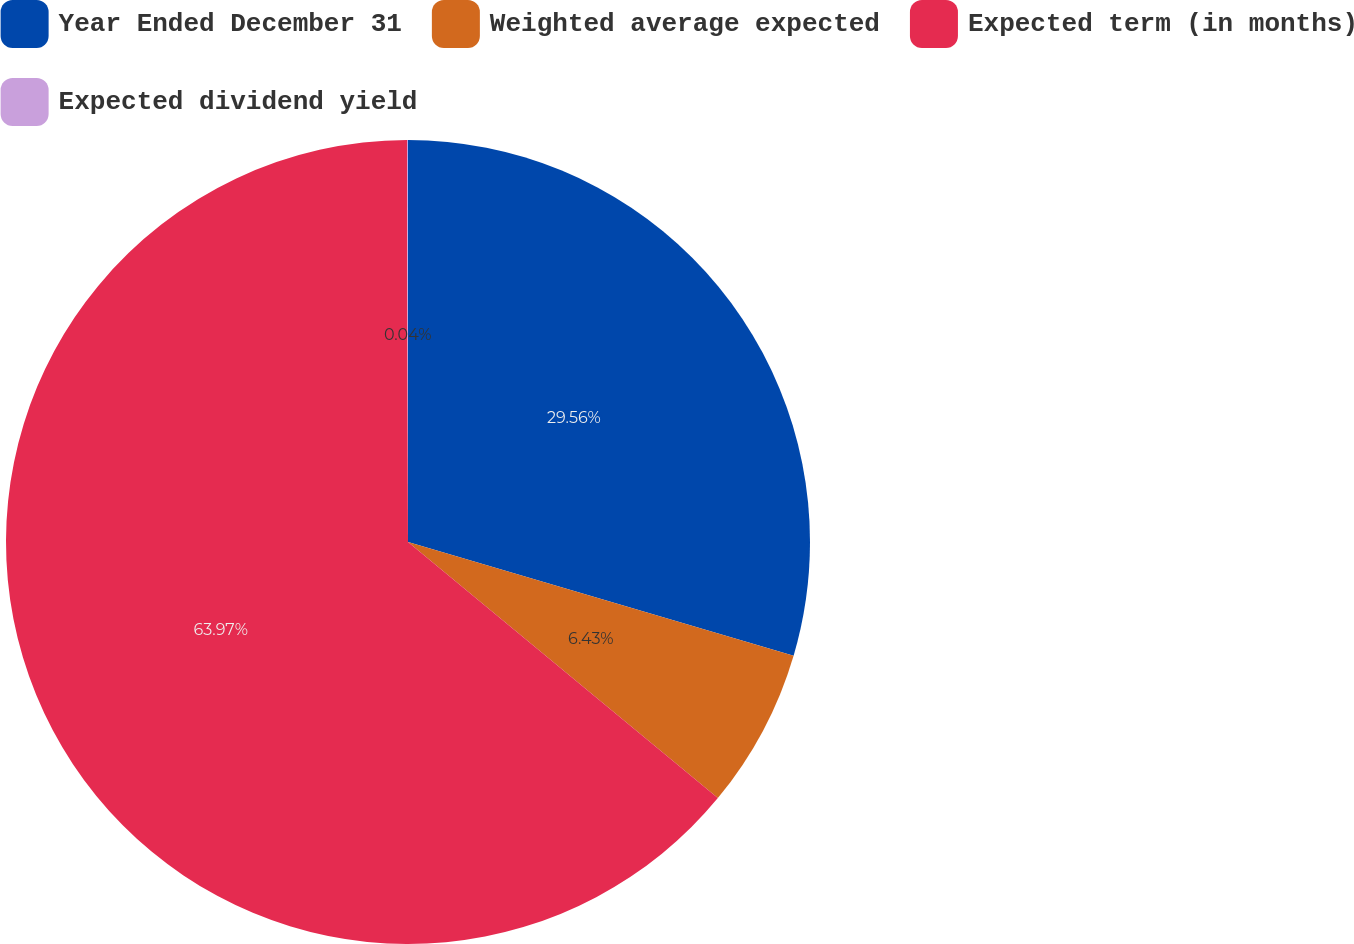<chart> <loc_0><loc_0><loc_500><loc_500><pie_chart><fcel>Year Ended December 31<fcel>Weighted average expected<fcel>Expected term (in months)<fcel>Expected dividend yield<nl><fcel>29.56%<fcel>6.43%<fcel>63.96%<fcel>0.04%<nl></chart> 